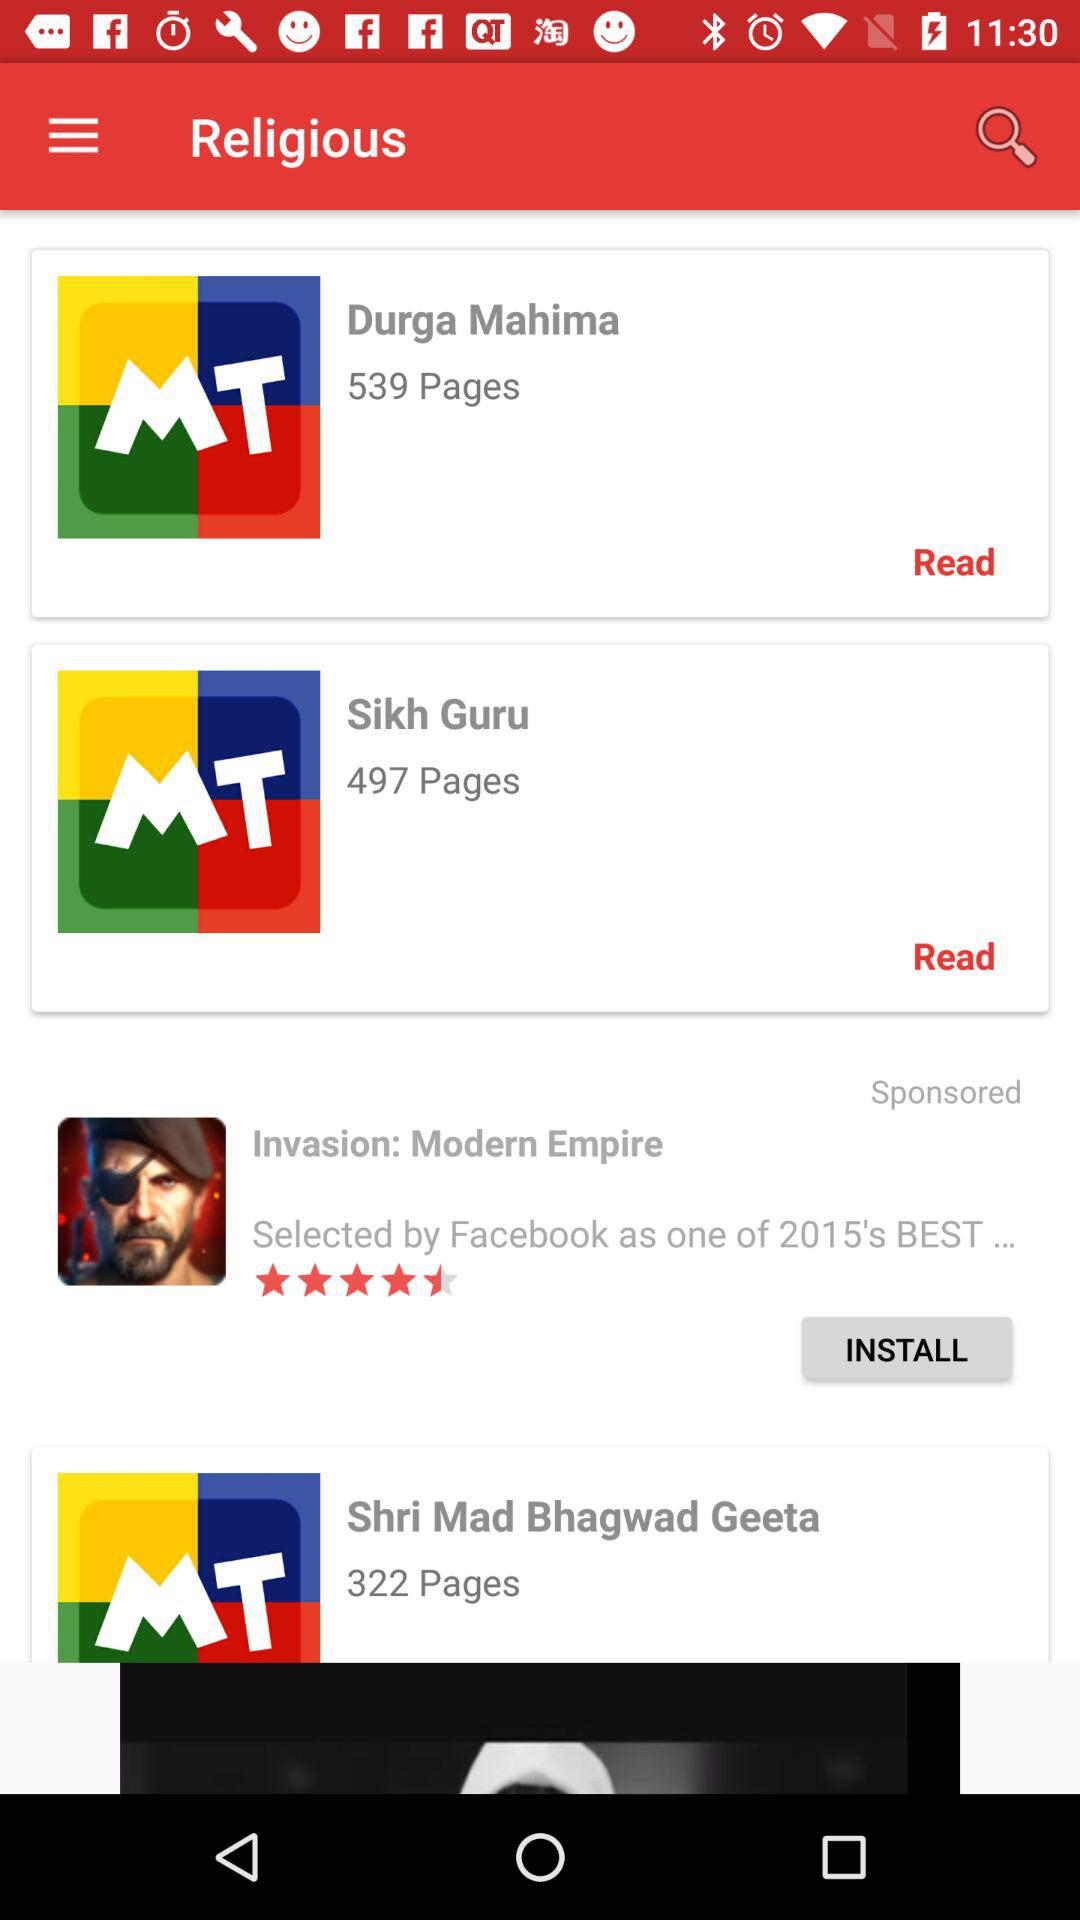What is the number of pages in total are there in "Shri Mad Bhagwad Geeta"? The total number of pages is 322. 